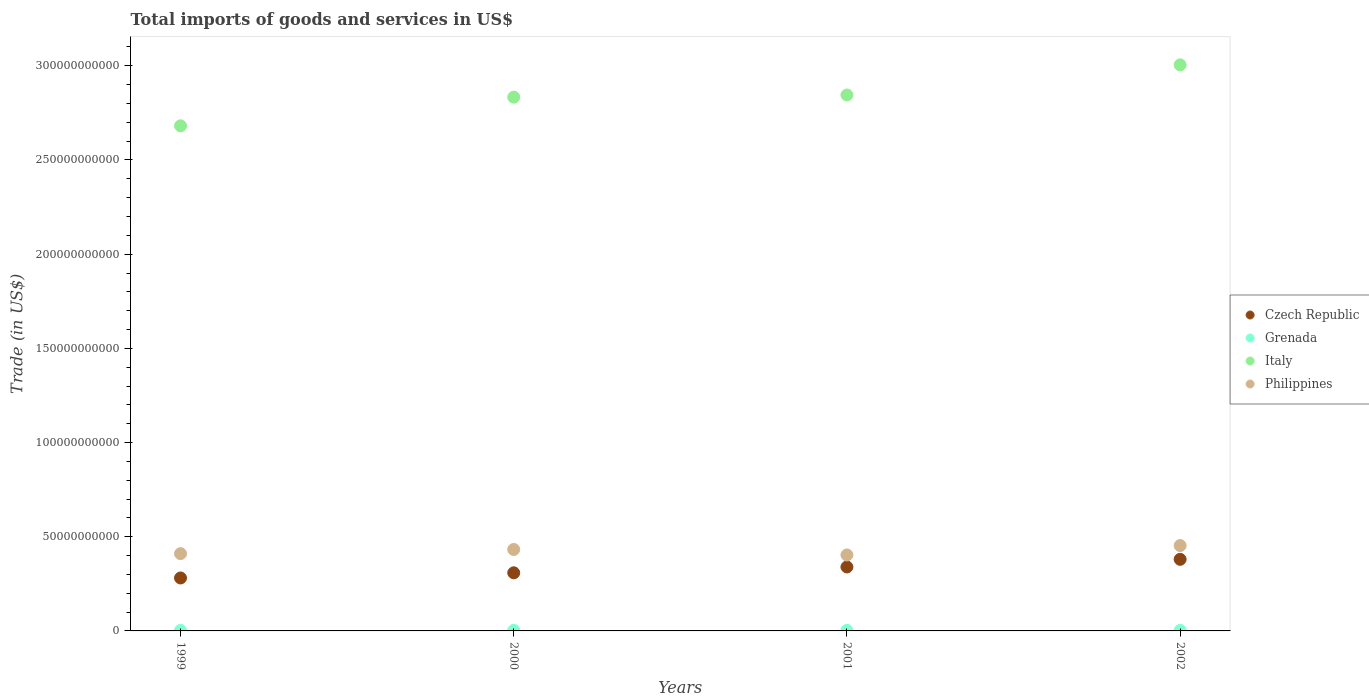How many different coloured dotlines are there?
Offer a very short reply. 4. Is the number of dotlines equal to the number of legend labels?
Offer a terse response. Yes. What is the total imports of goods and services in Italy in 2000?
Provide a short and direct response. 2.83e+11. Across all years, what is the maximum total imports of goods and services in Czech Republic?
Offer a very short reply. 3.80e+1. Across all years, what is the minimum total imports of goods and services in Czech Republic?
Make the answer very short. 2.81e+1. In which year was the total imports of goods and services in Grenada minimum?
Make the answer very short. 1999. What is the total total imports of goods and services in Grenada in the graph?
Provide a short and direct response. 1.13e+09. What is the difference between the total imports of goods and services in Czech Republic in 1999 and that in 2001?
Make the answer very short. -5.84e+09. What is the difference between the total imports of goods and services in Grenada in 2002 and the total imports of goods and services in Italy in 2001?
Provide a succinct answer. -2.84e+11. What is the average total imports of goods and services in Czech Republic per year?
Your answer should be very brief. 3.27e+1. In the year 2001, what is the difference between the total imports of goods and services in Czech Republic and total imports of goods and services in Italy?
Your answer should be compact. -2.51e+11. What is the ratio of the total imports of goods and services in Grenada in 1999 to that in 2002?
Make the answer very short. 0.98. Is the total imports of goods and services in Czech Republic in 2000 less than that in 2002?
Your response must be concise. Yes. What is the difference between the highest and the second highest total imports of goods and services in Czech Republic?
Offer a very short reply. 4.06e+09. What is the difference between the highest and the lowest total imports of goods and services in Philippines?
Offer a terse response. 4.98e+09. Is the sum of the total imports of goods and services in Czech Republic in 2000 and 2002 greater than the maximum total imports of goods and services in Philippines across all years?
Provide a succinct answer. Yes. Does the total imports of goods and services in Italy monotonically increase over the years?
Your response must be concise. Yes. How many dotlines are there?
Give a very brief answer. 4. Does the graph contain grids?
Give a very brief answer. No. What is the title of the graph?
Give a very brief answer. Total imports of goods and services in US$. Does "Poland" appear as one of the legend labels in the graph?
Your answer should be very brief. No. What is the label or title of the Y-axis?
Your answer should be compact. Trade (in US$). What is the Trade (in US$) of Czech Republic in 1999?
Provide a succinct answer. 2.81e+1. What is the Trade (in US$) of Grenada in 1999?
Your answer should be very brief. 2.66e+08. What is the Trade (in US$) in Italy in 1999?
Keep it short and to the point. 2.68e+11. What is the Trade (in US$) in Philippines in 1999?
Keep it short and to the point. 4.10e+1. What is the Trade (in US$) in Czech Republic in 2000?
Your answer should be compact. 3.08e+1. What is the Trade (in US$) in Grenada in 2000?
Give a very brief answer. 3.10e+08. What is the Trade (in US$) of Italy in 2000?
Your answer should be compact. 2.83e+11. What is the Trade (in US$) of Philippines in 2000?
Your answer should be very brief. 4.32e+1. What is the Trade (in US$) of Czech Republic in 2001?
Offer a terse response. 3.40e+1. What is the Trade (in US$) in Grenada in 2001?
Your answer should be compact. 2.80e+08. What is the Trade (in US$) in Italy in 2001?
Keep it short and to the point. 2.84e+11. What is the Trade (in US$) in Philippines in 2001?
Provide a short and direct response. 4.03e+1. What is the Trade (in US$) of Czech Republic in 2002?
Give a very brief answer. 3.80e+1. What is the Trade (in US$) in Grenada in 2002?
Offer a terse response. 2.72e+08. What is the Trade (in US$) of Italy in 2002?
Provide a succinct answer. 3.00e+11. What is the Trade (in US$) of Philippines in 2002?
Provide a succinct answer. 4.53e+1. Across all years, what is the maximum Trade (in US$) of Czech Republic?
Give a very brief answer. 3.80e+1. Across all years, what is the maximum Trade (in US$) in Grenada?
Offer a very short reply. 3.10e+08. Across all years, what is the maximum Trade (in US$) of Italy?
Give a very brief answer. 3.00e+11. Across all years, what is the maximum Trade (in US$) of Philippines?
Offer a very short reply. 4.53e+1. Across all years, what is the minimum Trade (in US$) of Czech Republic?
Your answer should be compact. 2.81e+1. Across all years, what is the minimum Trade (in US$) of Grenada?
Provide a succinct answer. 2.66e+08. Across all years, what is the minimum Trade (in US$) in Italy?
Offer a very short reply. 2.68e+11. Across all years, what is the minimum Trade (in US$) in Philippines?
Keep it short and to the point. 4.03e+1. What is the total Trade (in US$) in Czech Republic in the graph?
Keep it short and to the point. 1.31e+11. What is the total Trade (in US$) of Grenada in the graph?
Provide a short and direct response. 1.13e+09. What is the total Trade (in US$) in Italy in the graph?
Your response must be concise. 1.14e+12. What is the total Trade (in US$) of Philippines in the graph?
Keep it short and to the point. 1.70e+11. What is the difference between the Trade (in US$) of Czech Republic in 1999 and that in 2000?
Your response must be concise. -2.74e+09. What is the difference between the Trade (in US$) in Grenada in 1999 and that in 2000?
Keep it short and to the point. -4.38e+07. What is the difference between the Trade (in US$) of Italy in 1999 and that in 2000?
Make the answer very short. -1.52e+1. What is the difference between the Trade (in US$) of Philippines in 1999 and that in 2000?
Your answer should be compact. -2.22e+09. What is the difference between the Trade (in US$) of Czech Republic in 1999 and that in 2001?
Offer a very short reply. -5.84e+09. What is the difference between the Trade (in US$) of Grenada in 1999 and that in 2001?
Offer a terse response. -1.39e+07. What is the difference between the Trade (in US$) of Italy in 1999 and that in 2001?
Provide a succinct answer. -1.64e+1. What is the difference between the Trade (in US$) of Philippines in 1999 and that in 2001?
Offer a terse response. 6.87e+08. What is the difference between the Trade (in US$) in Czech Republic in 1999 and that in 2002?
Keep it short and to the point. -9.89e+09. What is the difference between the Trade (in US$) in Grenada in 1999 and that in 2002?
Offer a very short reply. -5.81e+06. What is the difference between the Trade (in US$) in Italy in 1999 and that in 2002?
Make the answer very short. -3.24e+1. What is the difference between the Trade (in US$) in Philippines in 1999 and that in 2002?
Provide a succinct answer. -4.29e+09. What is the difference between the Trade (in US$) in Czech Republic in 2000 and that in 2001?
Offer a very short reply. -3.10e+09. What is the difference between the Trade (in US$) in Grenada in 2000 and that in 2001?
Your answer should be very brief. 2.99e+07. What is the difference between the Trade (in US$) of Italy in 2000 and that in 2001?
Ensure brevity in your answer.  -1.15e+09. What is the difference between the Trade (in US$) in Philippines in 2000 and that in 2001?
Ensure brevity in your answer.  2.91e+09. What is the difference between the Trade (in US$) in Czech Republic in 2000 and that in 2002?
Your answer should be very brief. -7.16e+09. What is the difference between the Trade (in US$) of Grenada in 2000 and that in 2002?
Ensure brevity in your answer.  3.80e+07. What is the difference between the Trade (in US$) in Italy in 2000 and that in 2002?
Your answer should be compact. -1.71e+1. What is the difference between the Trade (in US$) in Philippines in 2000 and that in 2002?
Keep it short and to the point. -2.07e+09. What is the difference between the Trade (in US$) in Czech Republic in 2001 and that in 2002?
Offer a very short reply. -4.06e+09. What is the difference between the Trade (in US$) of Grenada in 2001 and that in 2002?
Your answer should be very brief. 8.10e+06. What is the difference between the Trade (in US$) in Italy in 2001 and that in 2002?
Provide a short and direct response. -1.60e+1. What is the difference between the Trade (in US$) of Philippines in 2001 and that in 2002?
Offer a very short reply. -4.98e+09. What is the difference between the Trade (in US$) in Czech Republic in 1999 and the Trade (in US$) in Grenada in 2000?
Your response must be concise. 2.78e+1. What is the difference between the Trade (in US$) in Czech Republic in 1999 and the Trade (in US$) in Italy in 2000?
Your response must be concise. -2.55e+11. What is the difference between the Trade (in US$) of Czech Republic in 1999 and the Trade (in US$) of Philippines in 2000?
Ensure brevity in your answer.  -1.51e+1. What is the difference between the Trade (in US$) in Grenada in 1999 and the Trade (in US$) in Italy in 2000?
Offer a very short reply. -2.83e+11. What is the difference between the Trade (in US$) in Grenada in 1999 and the Trade (in US$) in Philippines in 2000?
Your answer should be compact. -4.30e+1. What is the difference between the Trade (in US$) in Italy in 1999 and the Trade (in US$) in Philippines in 2000?
Make the answer very short. 2.25e+11. What is the difference between the Trade (in US$) in Czech Republic in 1999 and the Trade (in US$) in Grenada in 2001?
Your answer should be very brief. 2.78e+1. What is the difference between the Trade (in US$) of Czech Republic in 1999 and the Trade (in US$) of Italy in 2001?
Your response must be concise. -2.56e+11. What is the difference between the Trade (in US$) of Czech Republic in 1999 and the Trade (in US$) of Philippines in 2001?
Provide a succinct answer. -1.22e+1. What is the difference between the Trade (in US$) of Grenada in 1999 and the Trade (in US$) of Italy in 2001?
Offer a terse response. -2.84e+11. What is the difference between the Trade (in US$) in Grenada in 1999 and the Trade (in US$) in Philippines in 2001?
Provide a short and direct response. -4.01e+1. What is the difference between the Trade (in US$) of Italy in 1999 and the Trade (in US$) of Philippines in 2001?
Offer a terse response. 2.28e+11. What is the difference between the Trade (in US$) of Czech Republic in 1999 and the Trade (in US$) of Grenada in 2002?
Keep it short and to the point. 2.78e+1. What is the difference between the Trade (in US$) in Czech Republic in 1999 and the Trade (in US$) in Italy in 2002?
Offer a terse response. -2.72e+11. What is the difference between the Trade (in US$) of Czech Republic in 1999 and the Trade (in US$) of Philippines in 2002?
Your answer should be compact. -1.72e+1. What is the difference between the Trade (in US$) of Grenada in 1999 and the Trade (in US$) of Italy in 2002?
Ensure brevity in your answer.  -3.00e+11. What is the difference between the Trade (in US$) of Grenada in 1999 and the Trade (in US$) of Philippines in 2002?
Make the answer very short. -4.50e+1. What is the difference between the Trade (in US$) in Italy in 1999 and the Trade (in US$) in Philippines in 2002?
Provide a short and direct response. 2.23e+11. What is the difference between the Trade (in US$) in Czech Republic in 2000 and the Trade (in US$) in Grenada in 2001?
Offer a very short reply. 3.06e+1. What is the difference between the Trade (in US$) of Czech Republic in 2000 and the Trade (in US$) of Italy in 2001?
Your response must be concise. -2.54e+11. What is the difference between the Trade (in US$) of Czech Republic in 2000 and the Trade (in US$) of Philippines in 2001?
Ensure brevity in your answer.  -9.48e+09. What is the difference between the Trade (in US$) in Grenada in 2000 and the Trade (in US$) in Italy in 2001?
Make the answer very short. -2.84e+11. What is the difference between the Trade (in US$) in Grenada in 2000 and the Trade (in US$) in Philippines in 2001?
Keep it short and to the point. -4.00e+1. What is the difference between the Trade (in US$) in Italy in 2000 and the Trade (in US$) in Philippines in 2001?
Offer a very short reply. 2.43e+11. What is the difference between the Trade (in US$) in Czech Republic in 2000 and the Trade (in US$) in Grenada in 2002?
Provide a short and direct response. 3.06e+1. What is the difference between the Trade (in US$) of Czech Republic in 2000 and the Trade (in US$) of Italy in 2002?
Provide a succinct answer. -2.70e+11. What is the difference between the Trade (in US$) in Czech Republic in 2000 and the Trade (in US$) in Philippines in 2002?
Give a very brief answer. -1.45e+1. What is the difference between the Trade (in US$) in Grenada in 2000 and the Trade (in US$) in Italy in 2002?
Keep it short and to the point. -3.00e+11. What is the difference between the Trade (in US$) of Grenada in 2000 and the Trade (in US$) of Philippines in 2002?
Give a very brief answer. -4.50e+1. What is the difference between the Trade (in US$) in Italy in 2000 and the Trade (in US$) in Philippines in 2002?
Ensure brevity in your answer.  2.38e+11. What is the difference between the Trade (in US$) in Czech Republic in 2001 and the Trade (in US$) in Grenada in 2002?
Your answer should be compact. 3.37e+1. What is the difference between the Trade (in US$) of Czech Republic in 2001 and the Trade (in US$) of Italy in 2002?
Ensure brevity in your answer.  -2.67e+11. What is the difference between the Trade (in US$) in Czech Republic in 2001 and the Trade (in US$) in Philippines in 2002?
Keep it short and to the point. -1.14e+1. What is the difference between the Trade (in US$) of Grenada in 2001 and the Trade (in US$) of Italy in 2002?
Make the answer very short. -3.00e+11. What is the difference between the Trade (in US$) in Grenada in 2001 and the Trade (in US$) in Philippines in 2002?
Your response must be concise. -4.50e+1. What is the difference between the Trade (in US$) of Italy in 2001 and the Trade (in US$) of Philippines in 2002?
Offer a terse response. 2.39e+11. What is the average Trade (in US$) of Czech Republic per year?
Provide a short and direct response. 3.27e+1. What is the average Trade (in US$) of Grenada per year?
Your response must be concise. 2.82e+08. What is the average Trade (in US$) of Italy per year?
Make the answer very short. 2.84e+11. What is the average Trade (in US$) in Philippines per year?
Make the answer very short. 4.25e+1. In the year 1999, what is the difference between the Trade (in US$) of Czech Republic and Trade (in US$) of Grenada?
Your answer should be compact. 2.78e+1. In the year 1999, what is the difference between the Trade (in US$) of Czech Republic and Trade (in US$) of Italy?
Ensure brevity in your answer.  -2.40e+11. In the year 1999, what is the difference between the Trade (in US$) of Czech Republic and Trade (in US$) of Philippines?
Your response must be concise. -1.29e+1. In the year 1999, what is the difference between the Trade (in US$) of Grenada and Trade (in US$) of Italy?
Provide a short and direct response. -2.68e+11. In the year 1999, what is the difference between the Trade (in US$) of Grenada and Trade (in US$) of Philippines?
Make the answer very short. -4.08e+1. In the year 1999, what is the difference between the Trade (in US$) in Italy and Trade (in US$) in Philippines?
Offer a terse response. 2.27e+11. In the year 2000, what is the difference between the Trade (in US$) of Czech Republic and Trade (in US$) of Grenada?
Your answer should be compact. 3.05e+1. In the year 2000, what is the difference between the Trade (in US$) in Czech Republic and Trade (in US$) in Italy?
Offer a very short reply. -2.52e+11. In the year 2000, what is the difference between the Trade (in US$) of Czech Republic and Trade (in US$) of Philippines?
Provide a succinct answer. -1.24e+1. In the year 2000, what is the difference between the Trade (in US$) in Grenada and Trade (in US$) in Italy?
Keep it short and to the point. -2.83e+11. In the year 2000, what is the difference between the Trade (in US$) in Grenada and Trade (in US$) in Philippines?
Ensure brevity in your answer.  -4.29e+1. In the year 2000, what is the difference between the Trade (in US$) of Italy and Trade (in US$) of Philippines?
Provide a succinct answer. 2.40e+11. In the year 2001, what is the difference between the Trade (in US$) of Czech Republic and Trade (in US$) of Grenada?
Provide a short and direct response. 3.37e+1. In the year 2001, what is the difference between the Trade (in US$) of Czech Republic and Trade (in US$) of Italy?
Ensure brevity in your answer.  -2.51e+11. In the year 2001, what is the difference between the Trade (in US$) of Czech Republic and Trade (in US$) of Philippines?
Give a very brief answer. -6.38e+09. In the year 2001, what is the difference between the Trade (in US$) in Grenada and Trade (in US$) in Italy?
Provide a succinct answer. -2.84e+11. In the year 2001, what is the difference between the Trade (in US$) in Grenada and Trade (in US$) in Philippines?
Your answer should be very brief. -4.00e+1. In the year 2001, what is the difference between the Trade (in US$) in Italy and Trade (in US$) in Philippines?
Your answer should be compact. 2.44e+11. In the year 2002, what is the difference between the Trade (in US$) in Czech Republic and Trade (in US$) in Grenada?
Keep it short and to the point. 3.77e+1. In the year 2002, what is the difference between the Trade (in US$) of Czech Republic and Trade (in US$) of Italy?
Ensure brevity in your answer.  -2.62e+11. In the year 2002, what is the difference between the Trade (in US$) in Czech Republic and Trade (in US$) in Philippines?
Provide a succinct answer. -7.30e+09. In the year 2002, what is the difference between the Trade (in US$) of Grenada and Trade (in US$) of Italy?
Offer a very short reply. -3.00e+11. In the year 2002, what is the difference between the Trade (in US$) in Grenada and Trade (in US$) in Philippines?
Provide a short and direct response. -4.50e+1. In the year 2002, what is the difference between the Trade (in US$) in Italy and Trade (in US$) in Philippines?
Offer a very short reply. 2.55e+11. What is the ratio of the Trade (in US$) of Czech Republic in 1999 to that in 2000?
Keep it short and to the point. 0.91. What is the ratio of the Trade (in US$) in Grenada in 1999 to that in 2000?
Keep it short and to the point. 0.86. What is the ratio of the Trade (in US$) of Italy in 1999 to that in 2000?
Give a very brief answer. 0.95. What is the ratio of the Trade (in US$) in Philippines in 1999 to that in 2000?
Your answer should be very brief. 0.95. What is the ratio of the Trade (in US$) of Czech Republic in 1999 to that in 2001?
Provide a succinct answer. 0.83. What is the ratio of the Trade (in US$) in Grenada in 1999 to that in 2001?
Make the answer very short. 0.95. What is the ratio of the Trade (in US$) in Italy in 1999 to that in 2001?
Keep it short and to the point. 0.94. What is the ratio of the Trade (in US$) of Philippines in 1999 to that in 2001?
Keep it short and to the point. 1.02. What is the ratio of the Trade (in US$) in Czech Republic in 1999 to that in 2002?
Offer a very short reply. 0.74. What is the ratio of the Trade (in US$) of Grenada in 1999 to that in 2002?
Make the answer very short. 0.98. What is the ratio of the Trade (in US$) of Italy in 1999 to that in 2002?
Offer a very short reply. 0.89. What is the ratio of the Trade (in US$) of Philippines in 1999 to that in 2002?
Provide a succinct answer. 0.91. What is the ratio of the Trade (in US$) of Czech Republic in 2000 to that in 2001?
Your response must be concise. 0.91. What is the ratio of the Trade (in US$) in Grenada in 2000 to that in 2001?
Your answer should be very brief. 1.11. What is the ratio of the Trade (in US$) in Philippines in 2000 to that in 2001?
Make the answer very short. 1.07. What is the ratio of the Trade (in US$) of Czech Republic in 2000 to that in 2002?
Ensure brevity in your answer.  0.81. What is the ratio of the Trade (in US$) of Grenada in 2000 to that in 2002?
Make the answer very short. 1.14. What is the ratio of the Trade (in US$) in Italy in 2000 to that in 2002?
Keep it short and to the point. 0.94. What is the ratio of the Trade (in US$) in Philippines in 2000 to that in 2002?
Provide a succinct answer. 0.95. What is the ratio of the Trade (in US$) in Czech Republic in 2001 to that in 2002?
Offer a very short reply. 0.89. What is the ratio of the Trade (in US$) in Grenada in 2001 to that in 2002?
Offer a very short reply. 1.03. What is the ratio of the Trade (in US$) of Italy in 2001 to that in 2002?
Offer a very short reply. 0.95. What is the ratio of the Trade (in US$) of Philippines in 2001 to that in 2002?
Provide a short and direct response. 0.89. What is the difference between the highest and the second highest Trade (in US$) of Czech Republic?
Make the answer very short. 4.06e+09. What is the difference between the highest and the second highest Trade (in US$) in Grenada?
Make the answer very short. 2.99e+07. What is the difference between the highest and the second highest Trade (in US$) in Italy?
Give a very brief answer. 1.60e+1. What is the difference between the highest and the second highest Trade (in US$) in Philippines?
Offer a terse response. 2.07e+09. What is the difference between the highest and the lowest Trade (in US$) of Czech Republic?
Your answer should be compact. 9.89e+09. What is the difference between the highest and the lowest Trade (in US$) in Grenada?
Ensure brevity in your answer.  4.38e+07. What is the difference between the highest and the lowest Trade (in US$) of Italy?
Your answer should be compact. 3.24e+1. What is the difference between the highest and the lowest Trade (in US$) in Philippines?
Offer a very short reply. 4.98e+09. 